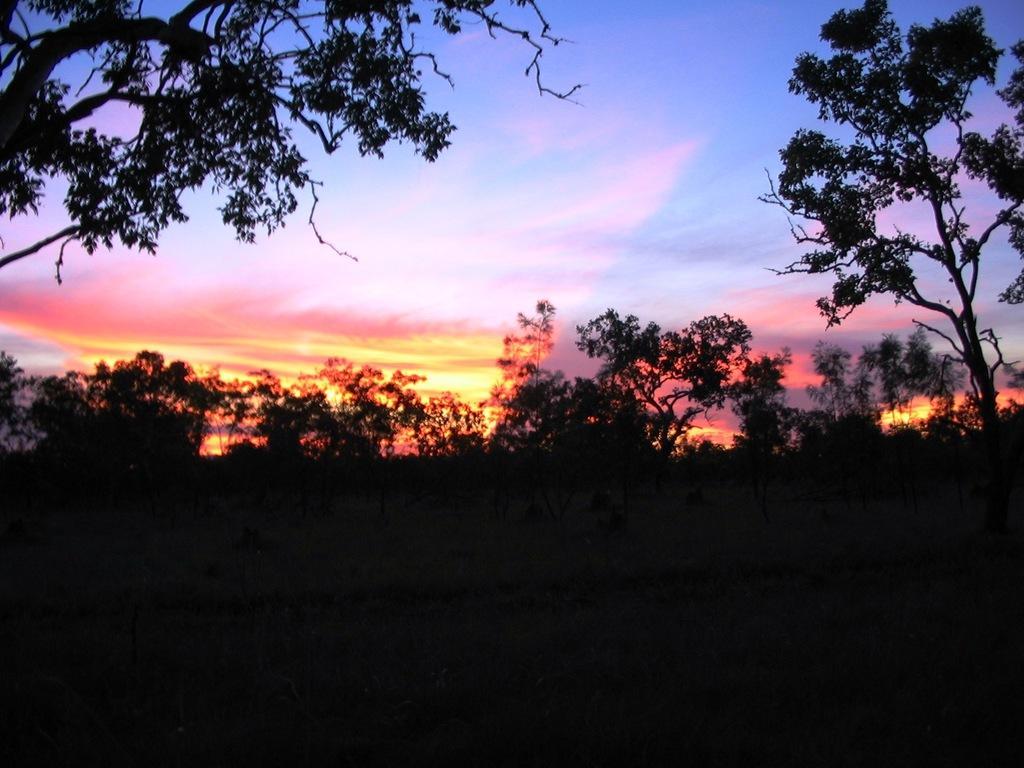Can you describe this image briefly? In this picture we can see few trees, in the background we can find clouds. 